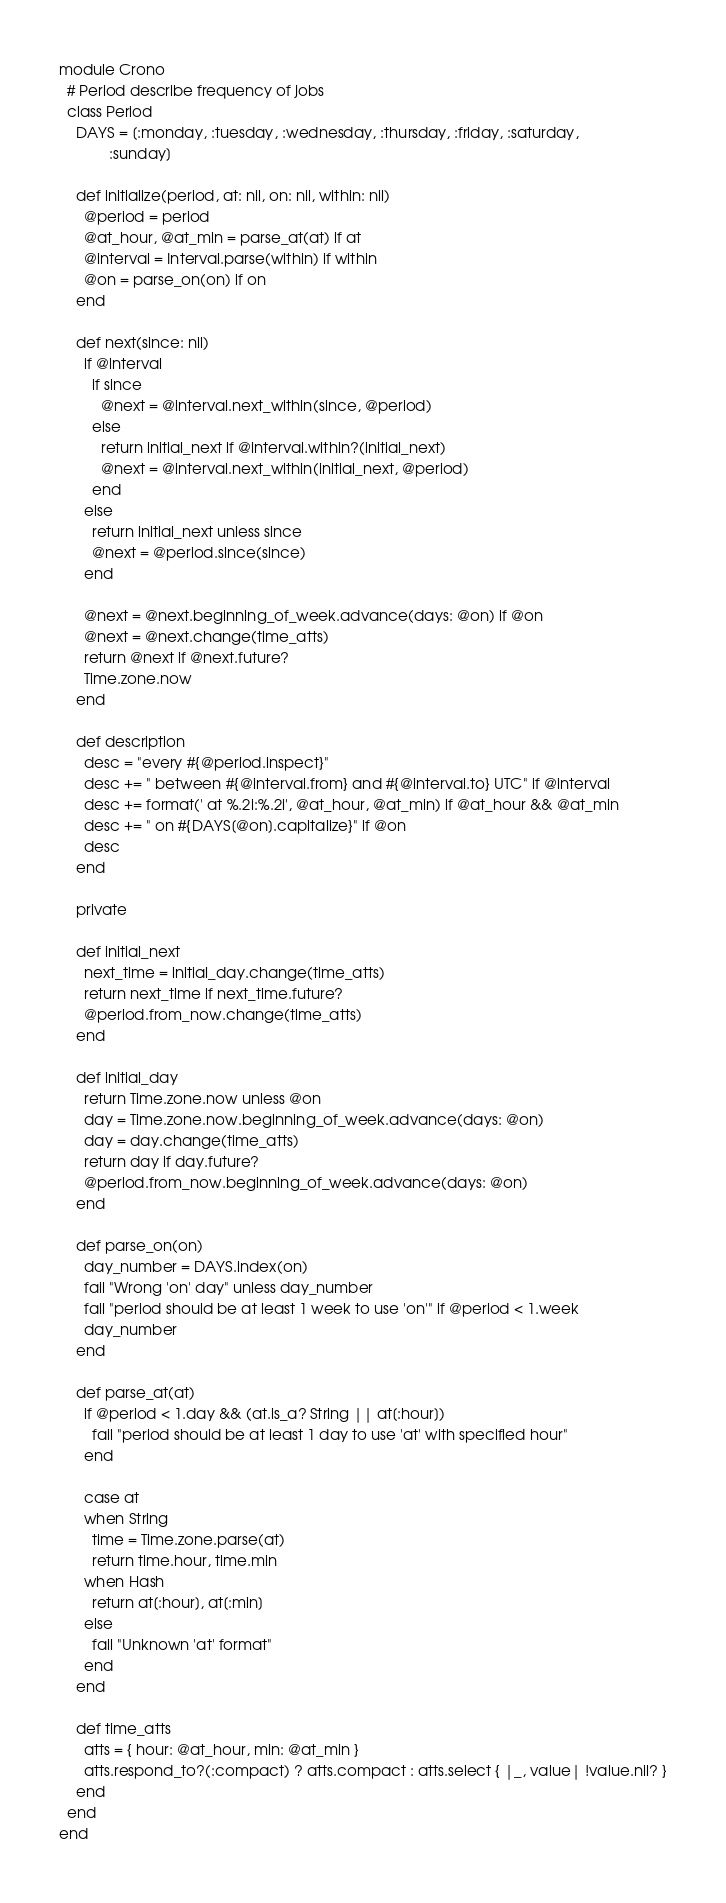Convert code to text. <code><loc_0><loc_0><loc_500><loc_500><_Ruby_>module Crono
  # Period describe frequency of jobs
  class Period
    DAYS = [:monday, :tuesday, :wednesday, :thursday, :friday, :saturday,
            :sunday]

    def initialize(period, at: nil, on: nil, within: nil)
      @period = period
      @at_hour, @at_min = parse_at(at) if at
      @interval = Interval.parse(within) if within
      @on = parse_on(on) if on
    end

    def next(since: nil)
      if @interval
        if since
          @next = @interval.next_within(since, @period)
        else
          return initial_next if @interval.within?(initial_next)
          @next = @interval.next_within(initial_next, @period)
        end
      else
        return initial_next unless since
        @next = @period.since(since)
      end

      @next = @next.beginning_of_week.advance(days: @on) if @on
      @next = @next.change(time_atts)
      return @next if @next.future?
      Time.zone.now
    end

    def description
      desc = "every #{@period.inspect}"
      desc += " between #{@interval.from} and #{@interval.to} UTC" if @interval
      desc += format(' at %.2i:%.2i', @at_hour, @at_min) if @at_hour && @at_min
      desc += " on #{DAYS[@on].capitalize}" if @on
      desc
    end

    private

    def initial_next
      next_time = initial_day.change(time_atts)
      return next_time if next_time.future?
      @period.from_now.change(time_atts)
    end

    def initial_day
      return Time.zone.now unless @on
      day = Time.zone.now.beginning_of_week.advance(days: @on)
      day = day.change(time_atts)
      return day if day.future?
      @period.from_now.beginning_of_week.advance(days: @on)
    end

    def parse_on(on)
      day_number = DAYS.index(on)
      fail "Wrong 'on' day" unless day_number
      fail "period should be at least 1 week to use 'on'" if @period < 1.week
      day_number
    end

    def parse_at(at)
      if @period < 1.day && (at.is_a? String || at[:hour])
        fail "period should be at least 1 day to use 'at' with specified hour"
      end

      case at
      when String
        time = Time.zone.parse(at)
        return time.hour, time.min
      when Hash
        return at[:hour], at[:min]
      else
        fail "Unknown 'at' format"
      end
    end

    def time_atts
      atts = { hour: @at_hour, min: @at_min }
      atts.respond_to?(:compact) ? atts.compact : atts.select { |_, value| !value.nil? }
    end
  end
end
</code> 